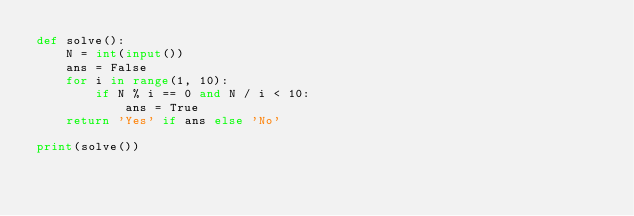Convert code to text. <code><loc_0><loc_0><loc_500><loc_500><_Python_>def solve():
    N = int(input())
    ans = False
    for i in range(1, 10):
        if N % i == 0 and N / i < 10:
            ans = True
    return 'Yes' if ans else 'No'

print(solve())</code> 